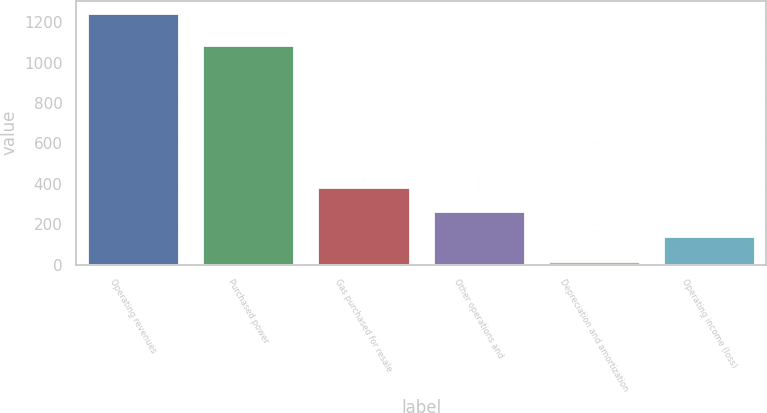Convert chart. <chart><loc_0><loc_0><loc_500><loc_500><bar_chart><fcel>Operating revenues<fcel>Purchased power<fcel>Gas purchased for resale<fcel>Other operations and<fcel>Depreciation and amortization<fcel>Operating income (loss)<nl><fcel>1244<fcel>1088<fcel>386.5<fcel>264<fcel>19<fcel>141.5<nl></chart> 